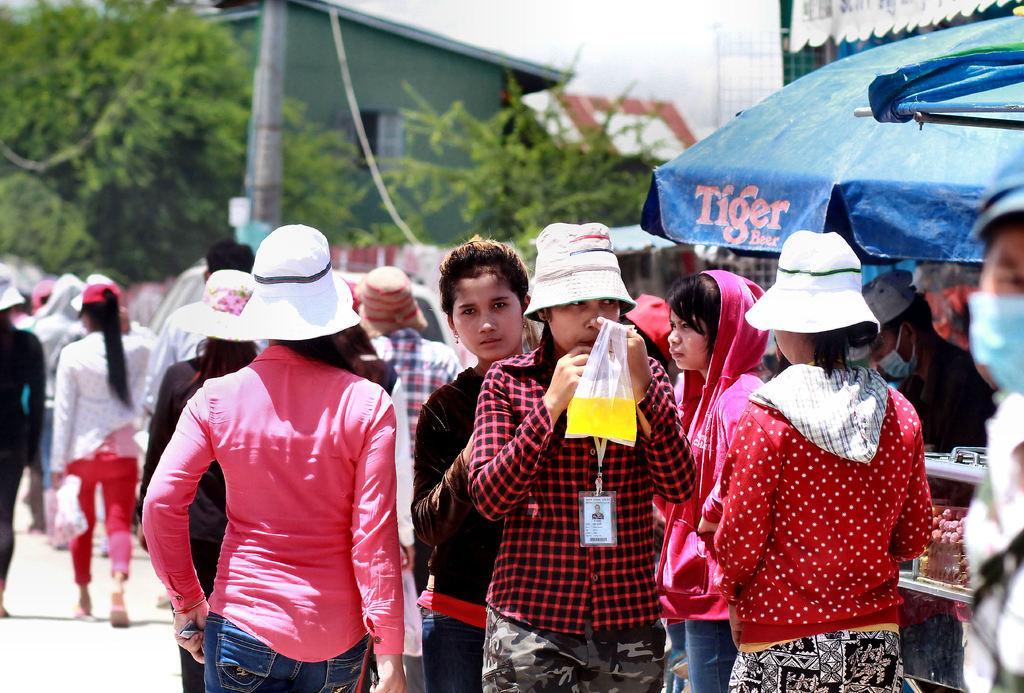In one or two sentences, can you explain what this image depicts? In the image in the center, we can see a few people are standing, few people are wearing hats and few people were holding some objects. In the background, we can see the sky, clouds, buildings, trees, banners, poles, tents and a few other objects. 